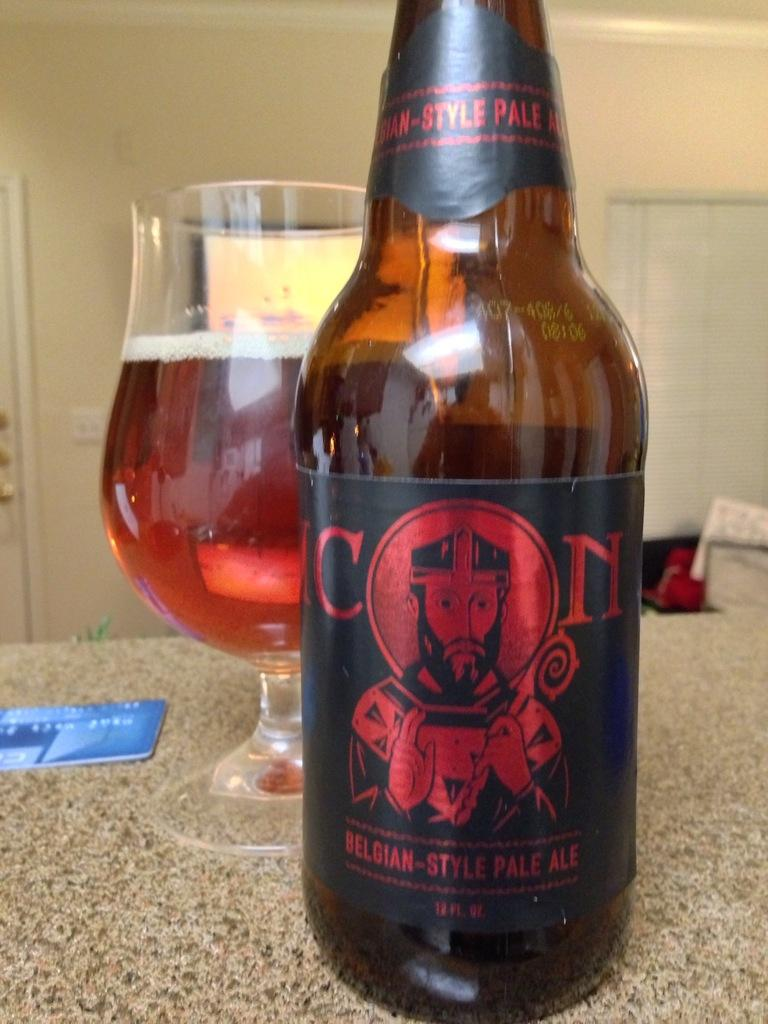What type of beverage container is present in the image? There is a wine bottle in the image. What type of glassware is present in the image? There is a wine glass in the image. What financial instrument is present in the image? There is an ATM card in the image. What shape is the route that the wine bottle is taking in the image? There is no route present in the image, as it is a still image and not a video or animation. 